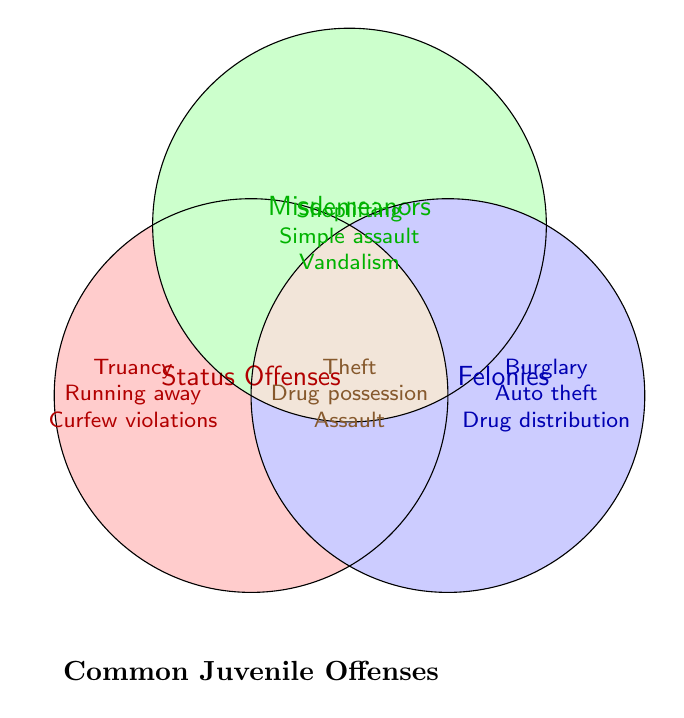What is the title of the figure? The label at the bottom of the diagram indicates its title.
Answer: Common Juvenile Offenses Which offenses are classified as status offenses? These offenses are listed inside the red circle on the left.
Answer: Truancy, Running away, Curfew violations Which offenses are classified as both misdemeanors and felonies? These offenses are placed in the intersection of the green and blue circles, which also visually overlap all three circles.
Answer: Theft, Drug possession, Assault How many offenses are identified only as felonies? Counting the offenses listed solely under the blue circle on the right gives the total.
Answer: Three How many offenses are classified as misdemeanors only? Counting the offenses within the green circle without intersecting with other circles provides the total.
Answer: Three Which offenses overlap between misdemeanors and status offenses? By observing the diagram, it becomes clear no offenses appear in the overlap between the green (misdemeanors) and red (status offenses) circles without also overlapping the blue (felonies) circle.
Answer: None Which categories have the offense 'Shoplifting'? 'Shoplifting' is listed in the green circle representing misdemeanors.
Answer: Misdemeanors If an offense is categorized as both a misdemeanor and a felony, which offenses could it be? These offenses are placed at the intersection of green and blue circles, also involving the overlap with the red circle.
Answer: Theft, Drug possession, Assault Which overlaps contain status offenses? Status offenses (red circle) do not overlap with either misdemeanors (green) or felonies (blue) without including all three categories.
Answer: None without involving all three categories 